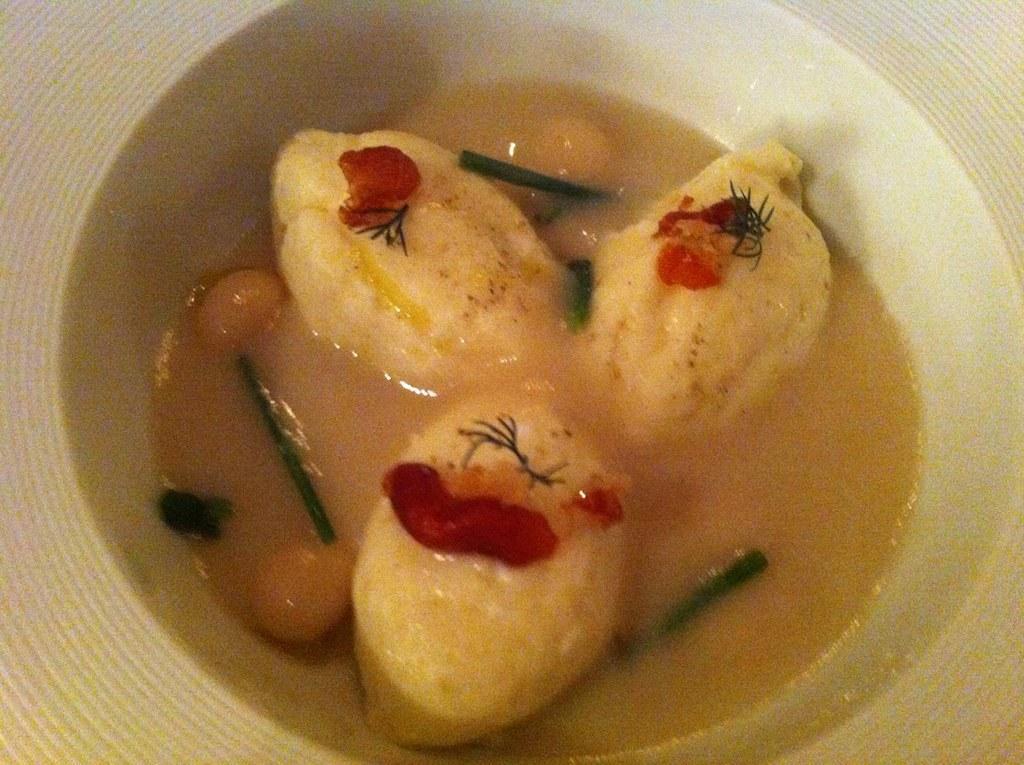How would you summarize this image in a sentence or two? In this picture I can see there is some food placed in a bowl. 